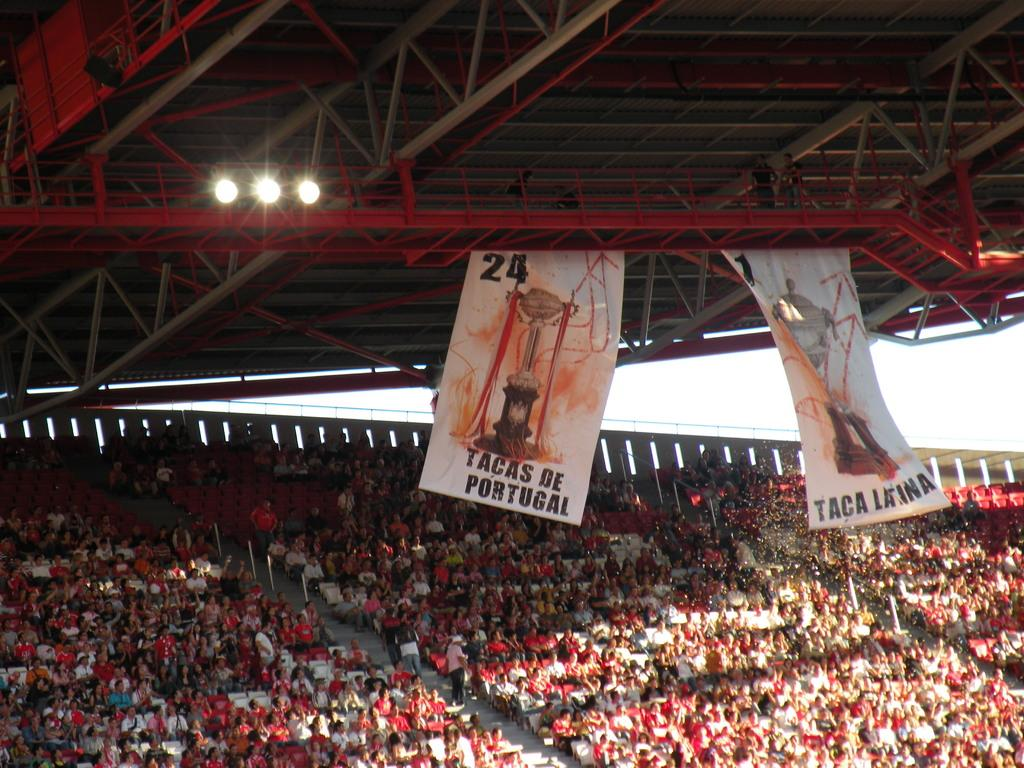<image>
Provide a brief description of the given image. A sign that reads Tacas De Portugal hangs above a crowd 